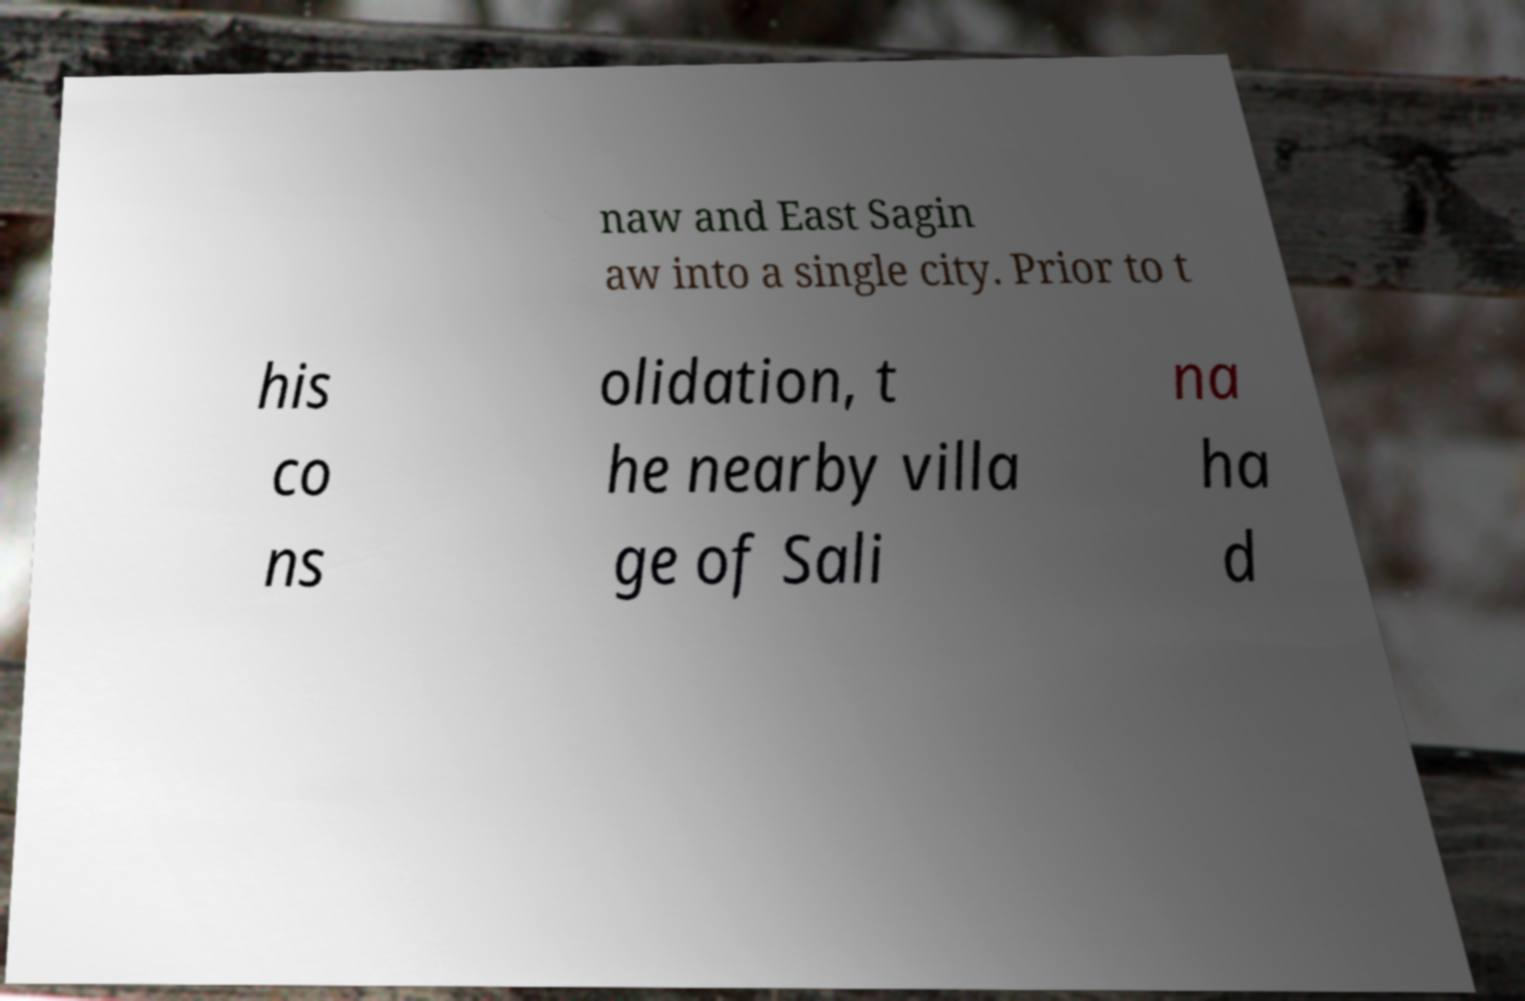What messages or text are displayed in this image? I need them in a readable, typed format. naw and East Sagin aw into a single city. Prior to t his co ns olidation, t he nearby villa ge of Sali na ha d 